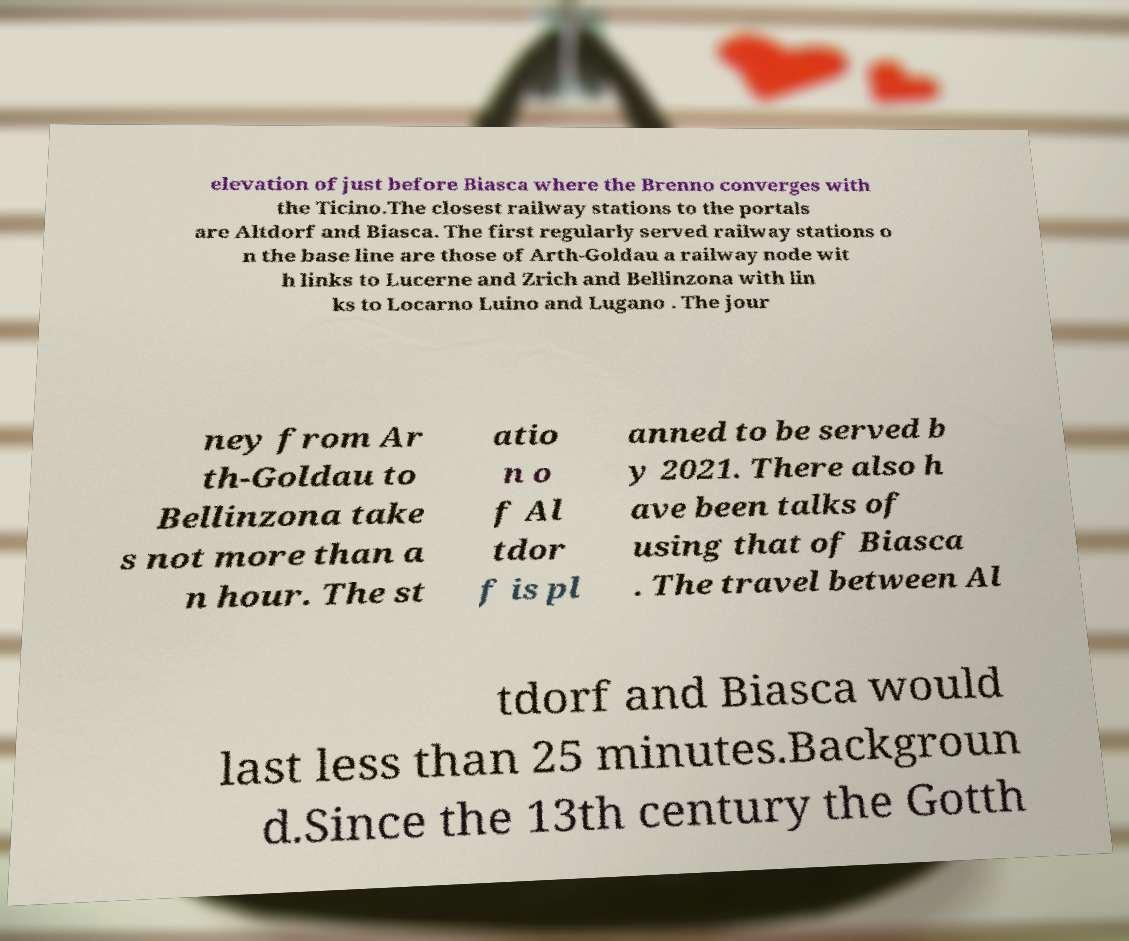Please read and relay the text visible in this image. What does it say? elevation of just before Biasca where the Brenno converges with the Ticino.The closest railway stations to the portals are Altdorf and Biasca. The first regularly served railway stations o n the base line are those of Arth-Goldau a railway node wit h links to Lucerne and Zrich and Bellinzona with lin ks to Locarno Luino and Lugano . The jour ney from Ar th-Goldau to Bellinzona take s not more than a n hour. The st atio n o f Al tdor f is pl anned to be served b y 2021. There also h ave been talks of using that of Biasca . The travel between Al tdorf and Biasca would last less than 25 minutes.Backgroun d.Since the 13th century the Gotth 